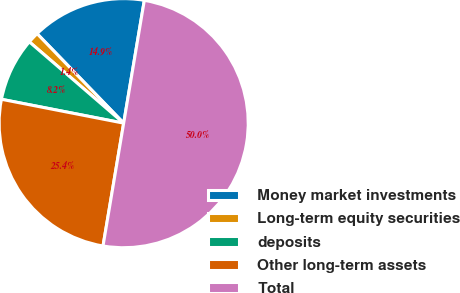Convert chart. <chart><loc_0><loc_0><loc_500><loc_500><pie_chart><fcel>Money market investments<fcel>Long-term equity securities<fcel>deposits<fcel>Other long-term assets<fcel>Total<nl><fcel>14.89%<fcel>1.44%<fcel>8.25%<fcel>25.42%<fcel>50.0%<nl></chart> 